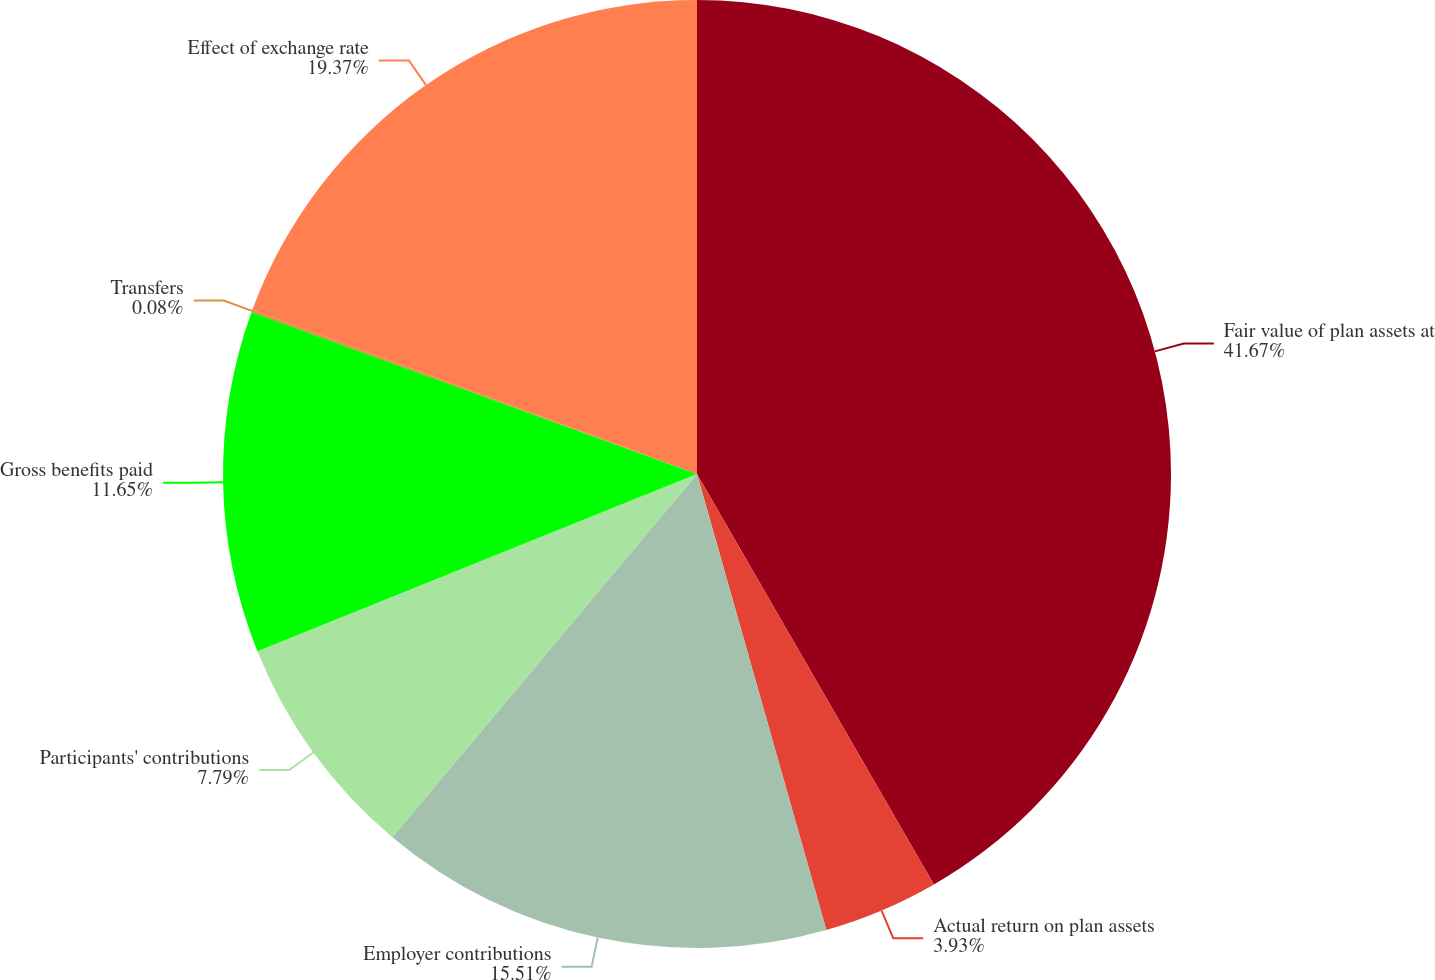<chart> <loc_0><loc_0><loc_500><loc_500><pie_chart><fcel>Fair value of plan assets at<fcel>Actual return on plan assets<fcel>Employer contributions<fcel>Participants' contributions<fcel>Gross benefits paid<fcel>Transfers<fcel>Effect of exchange rate<nl><fcel>41.67%<fcel>3.93%<fcel>15.51%<fcel>7.79%<fcel>11.65%<fcel>0.08%<fcel>19.37%<nl></chart> 